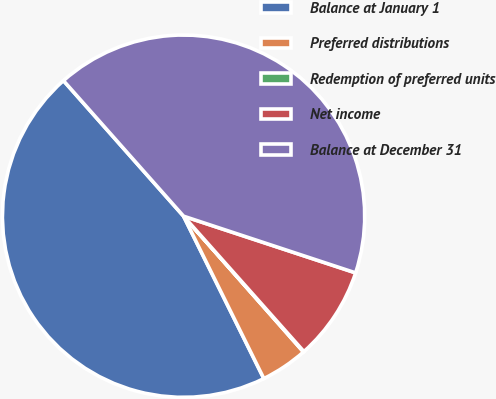Convert chart to OTSL. <chart><loc_0><loc_0><loc_500><loc_500><pie_chart><fcel>Balance at January 1<fcel>Preferred distributions<fcel>Redemption of preferred units<fcel>Net income<fcel>Balance at December 31<nl><fcel>45.77%<fcel>4.21%<fcel>0.05%<fcel>8.37%<fcel>41.61%<nl></chart> 